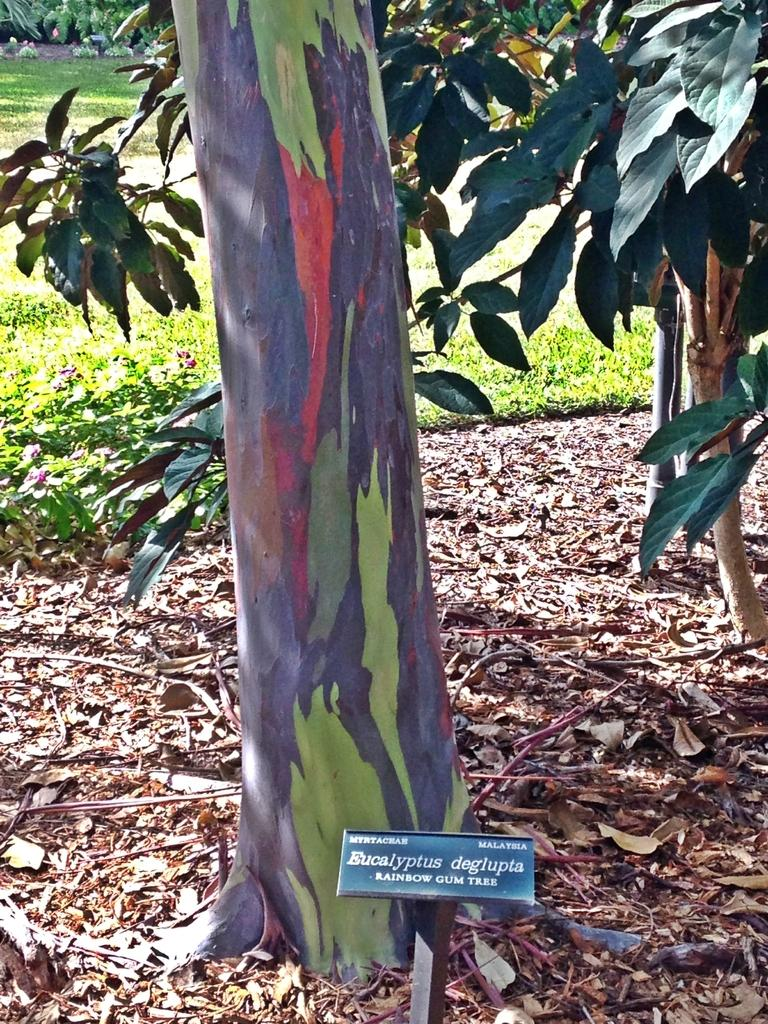What type of vegetation is present on the ground in the image? There are plants on the ground in the image. What can be found at the bottom of the image? There is a board with text at the bottom of the image. What type of natural environment is visible in the background of the image? There is grass visible in the background of the image. How many properties does the wren own in the image? There is no wren present in the image, so it is not possible to determine how many properties it might own. 